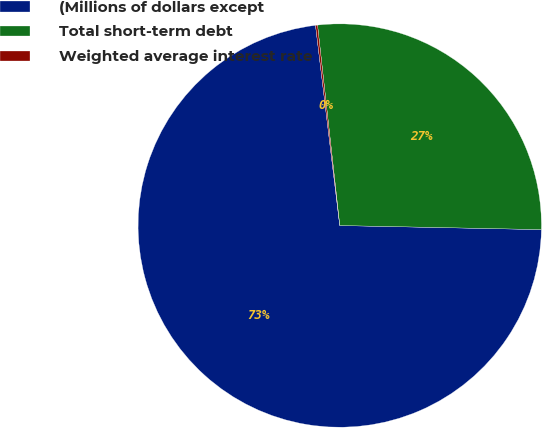Convert chart to OTSL. <chart><loc_0><loc_0><loc_500><loc_500><pie_chart><fcel>(Millions of dollars except<fcel>Total short-term debt<fcel>Weighted average interest rate<nl><fcel>72.76%<fcel>27.08%<fcel>0.16%<nl></chart> 